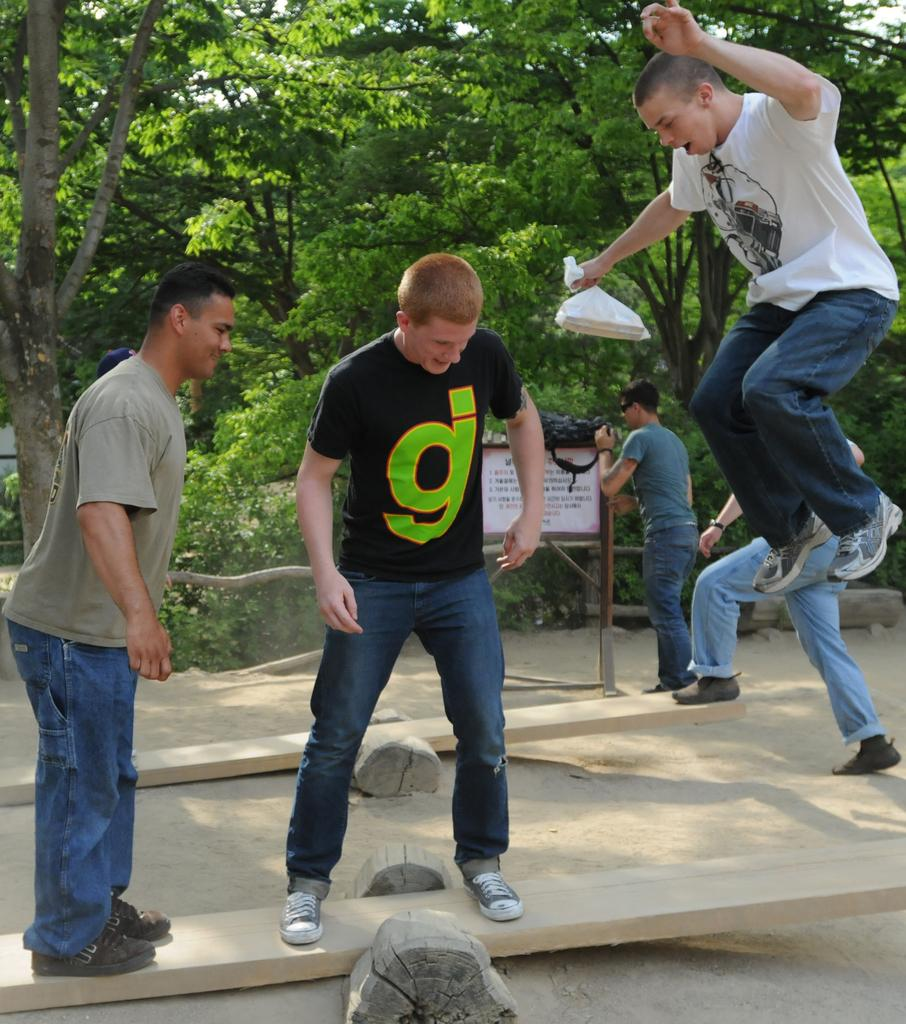What is happening with the people in the image? There are people standing in the image, and one man is in the air. What can be seen in the background of the image? There are trees, wooden objects, and a white color board in the background of the image. Are there any other objects visible in the background? Yes, there are other objects visible in the background of the image. How does the fear of the tub affect the people in the image? There is no tub present in the image, and therefore no fear of a tub can be observed. 